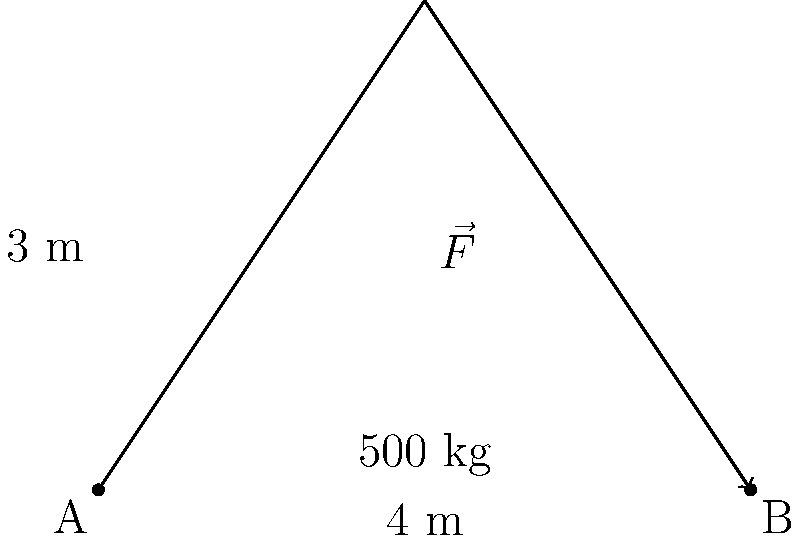You're setting up for an EDM festival, and you need to move a heavy DJ equipment setup weighing 500 kg. The setup needs to be moved 4 meters horizontally and lifted 3 meters vertically. What is the magnitude of the force vector $\vec{F}$ required to move the equipment, assuming friction is negligible? Let's approach this step-by-step:

1) First, we need to identify the components of the force vector:
   - Horizontal component: 4 m
   - Vertical component: 3 m

2) The weight of the equipment affects only the vertical component:
   $F_y = 500 \text{ kg} \times 9.8 \text{ m/s}^2 = 4900 \text{ N}$

3) We don't need any horizontal force to move the equipment (assuming no friction), so $F_x = 0 \text{ N}$

4) The magnitude of the force vector can be calculated using the Pythagorean theorem:
   $|\vec{F}| = \sqrt{F_x^2 + F_y^2}$

5) Plugging in the values:
   $|\vec{F}| = \sqrt{0^2 + 4900^2} = \sqrt{24,010,000} = 4900 \text{ N}$

Therefore, the magnitude of the force vector needed to move the DJ equipment is 4900 N.
Answer: 4900 N 